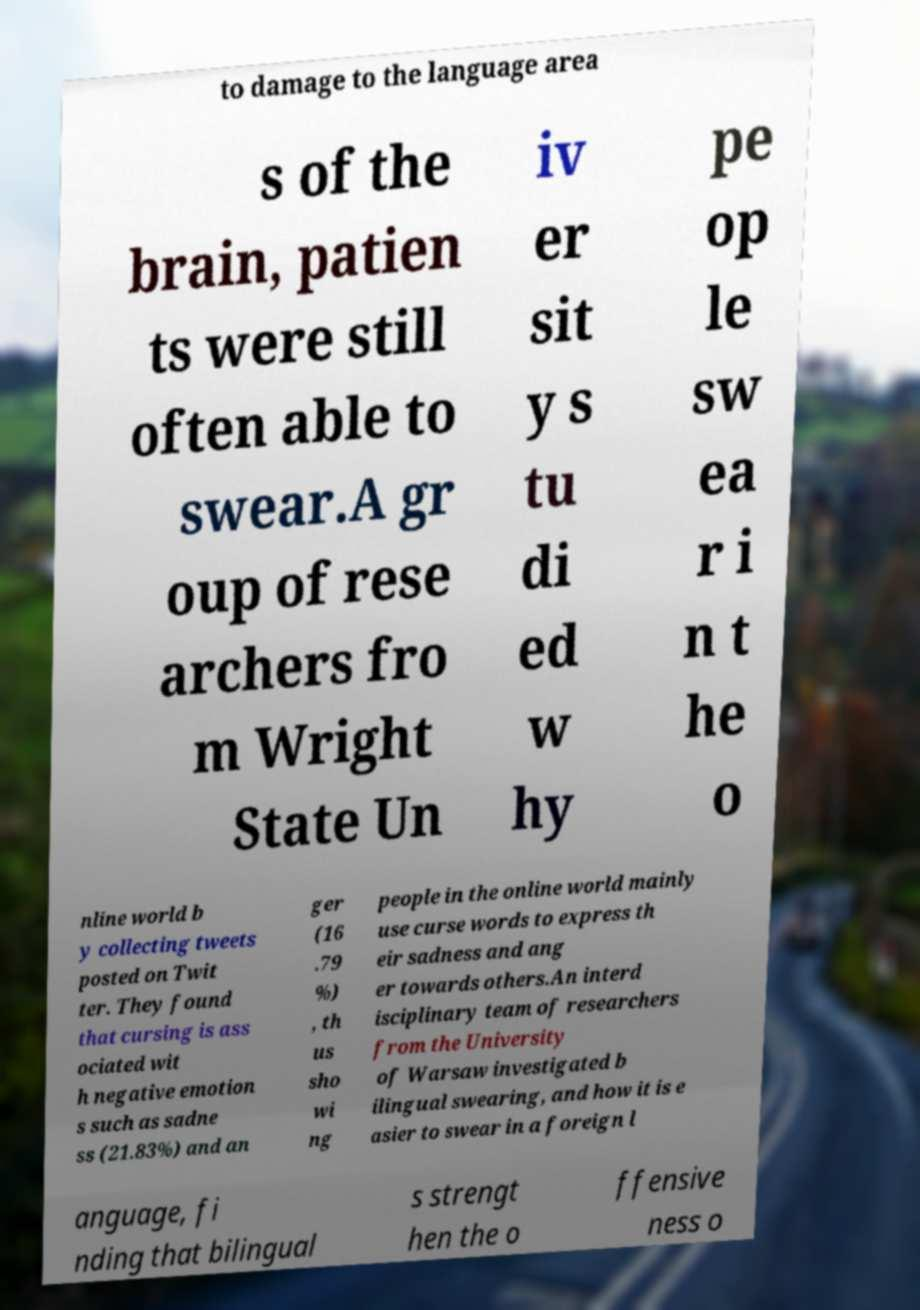For documentation purposes, I need the text within this image transcribed. Could you provide that? to damage to the language area s of the brain, patien ts were still often able to swear.A gr oup of rese archers fro m Wright State Un iv er sit y s tu di ed w hy pe op le sw ea r i n t he o nline world b y collecting tweets posted on Twit ter. They found that cursing is ass ociated wit h negative emotion s such as sadne ss (21.83%) and an ger (16 .79 %) , th us sho wi ng people in the online world mainly use curse words to express th eir sadness and ang er towards others.An interd isciplinary team of researchers from the University of Warsaw investigated b ilingual swearing, and how it is e asier to swear in a foreign l anguage, fi nding that bilingual s strengt hen the o ffensive ness o 